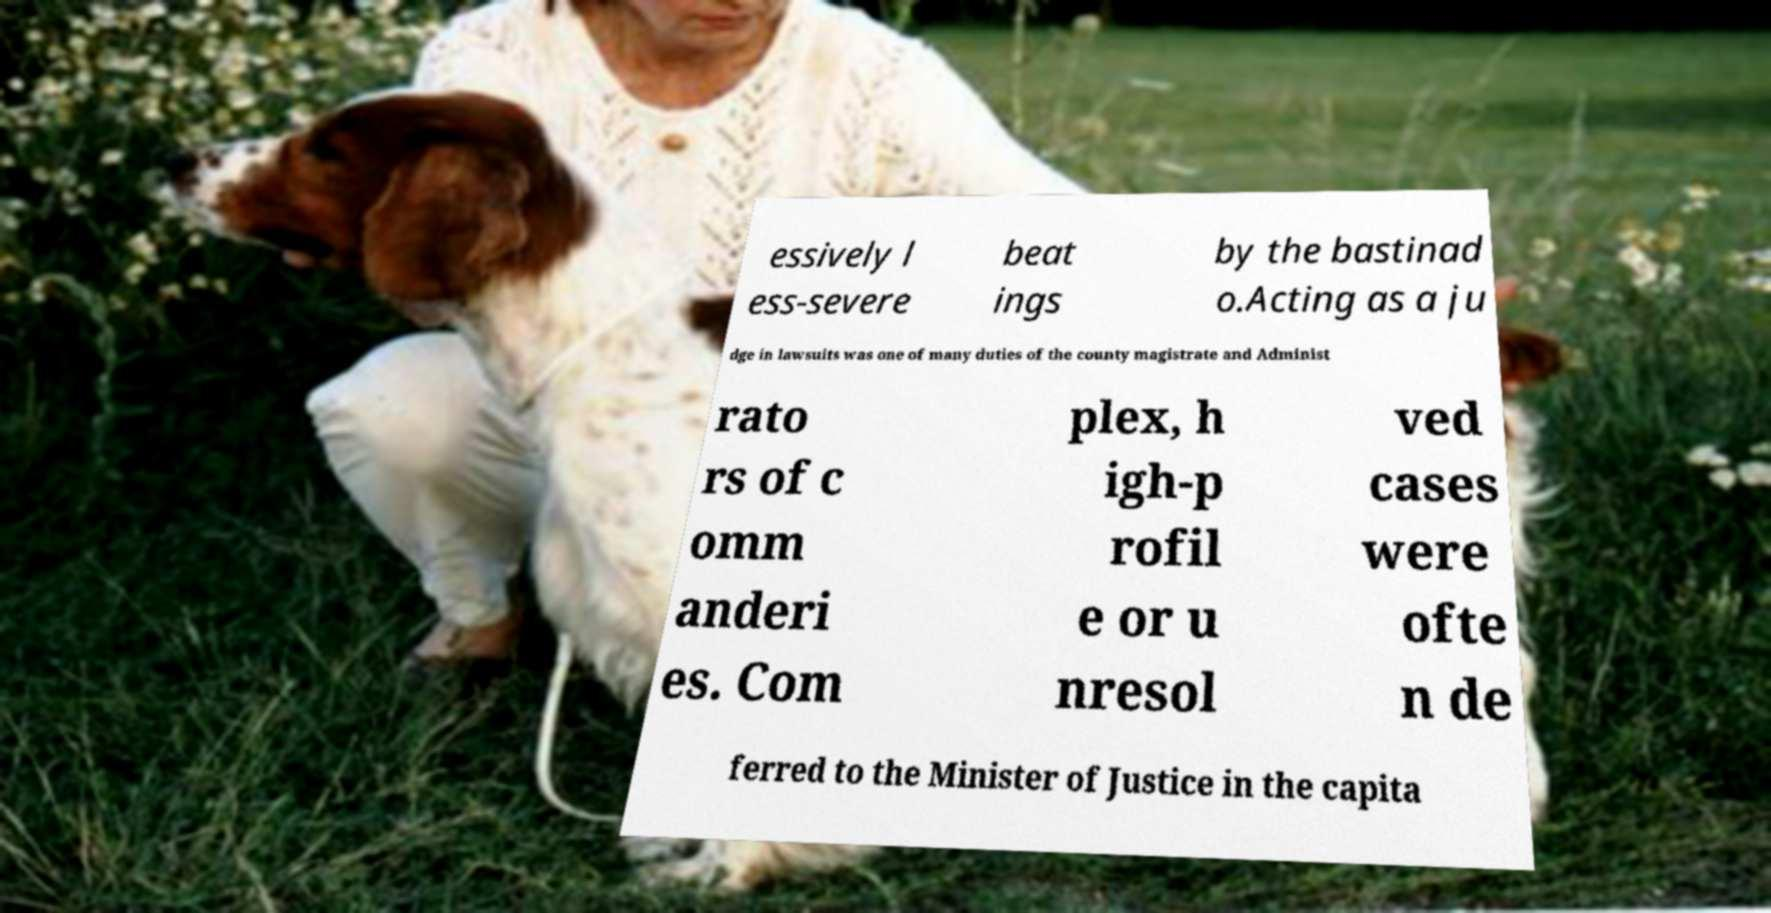Could you assist in decoding the text presented in this image and type it out clearly? essively l ess-severe beat ings by the bastinad o.Acting as a ju dge in lawsuits was one of many duties of the county magistrate and Administ rato rs of c omm anderi es. Com plex, h igh-p rofil e or u nresol ved cases were ofte n de ferred to the Minister of Justice in the capita 